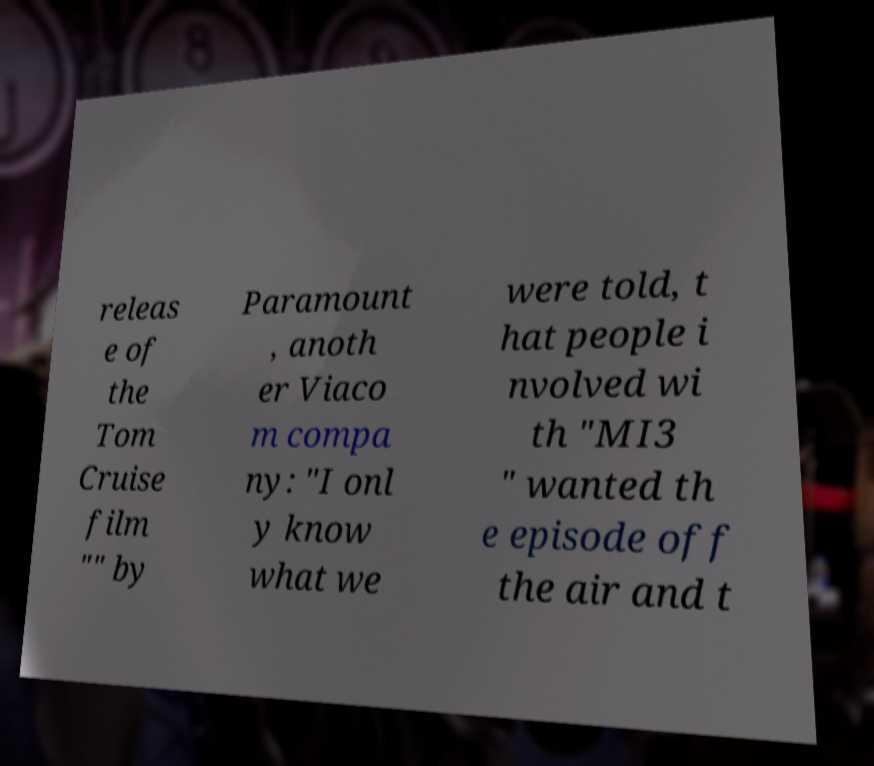For documentation purposes, I need the text within this image transcribed. Could you provide that? releas e of the Tom Cruise film "" by Paramount , anoth er Viaco m compa ny: "I onl y know what we were told, t hat people i nvolved wi th "MI3 " wanted th e episode off the air and t 